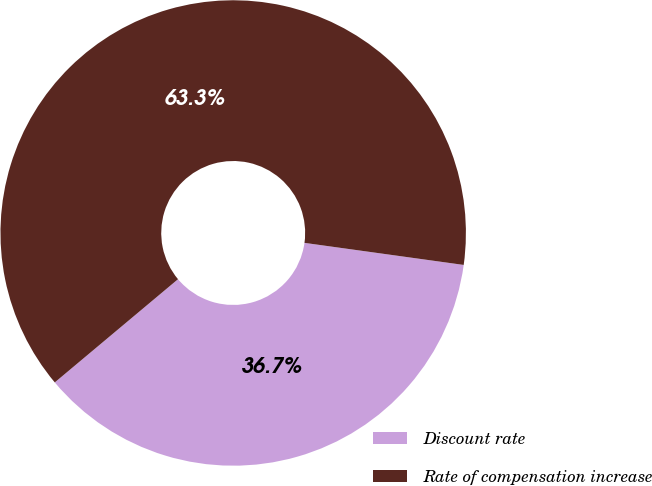Convert chart to OTSL. <chart><loc_0><loc_0><loc_500><loc_500><pie_chart><fcel>Discount rate<fcel>Rate of compensation increase<nl><fcel>36.71%<fcel>63.29%<nl></chart> 